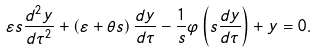<formula> <loc_0><loc_0><loc_500><loc_500>\varepsilon s \frac { d ^ { 2 } y } { d \tau ^ { 2 } } + \left ( \varepsilon + \theta s \right ) \frac { d y } { d \tau } - \frac { 1 } { s } \varphi \left ( s \frac { d y } { d \tau } \right ) + y = 0 .</formula> 